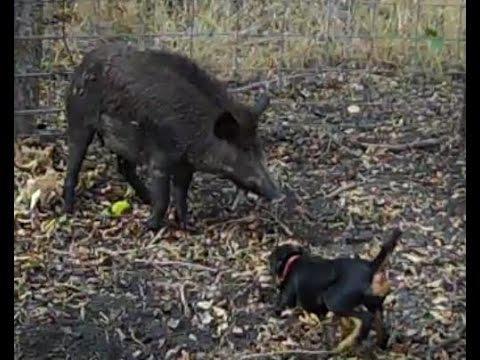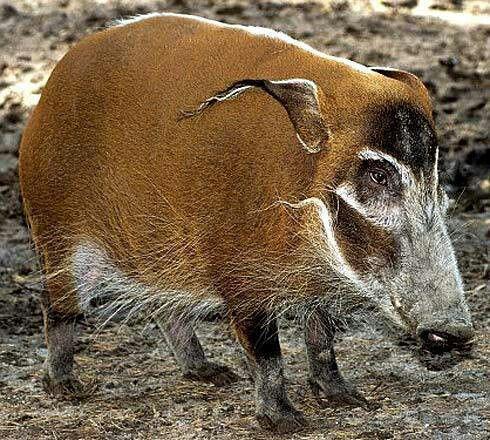The first image is the image on the left, the second image is the image on the right. Considering the images on both sides, is "All pigs shown in the images face the same direction." valid? Answer yes or no. Yes. The first image is the image on the left, the second image is the image on the right. Evaluate the accuracy of this statement regarding the images: "There are two hogs in total.". Is it true? Answer yes or no. Yes. 